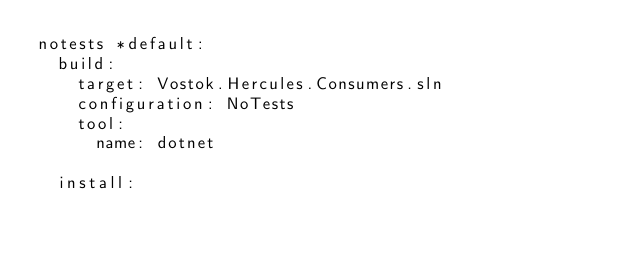Convert code to text. <code><loc_0><loc_0><loc_500><loc_500><_YAML_>notests *default:
  build:
    target: Vostok.Hercules.Consumers.sln
    configuration: NoTests
    tool:
      name: dotnet

  install:</code> 